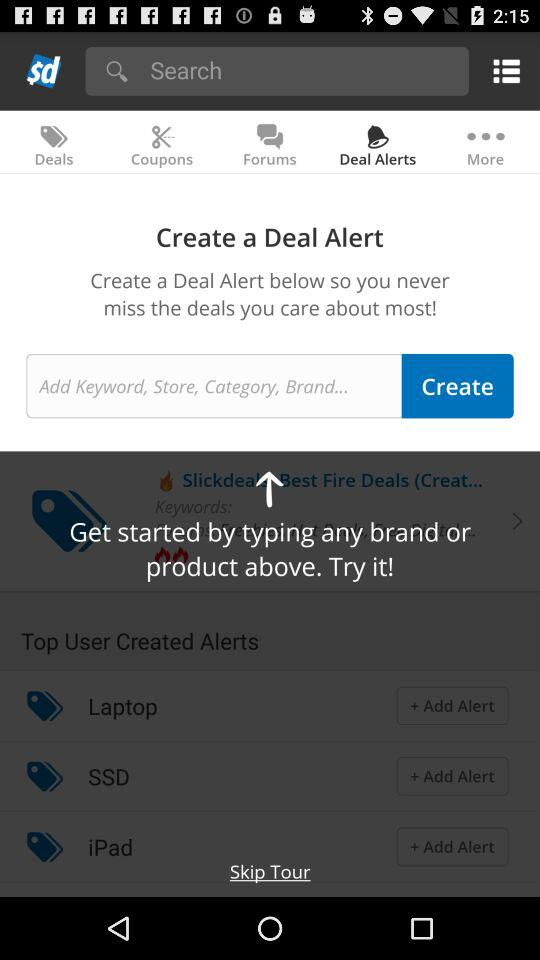What is the selected tab? The selected tab is "Deal Alerts". 